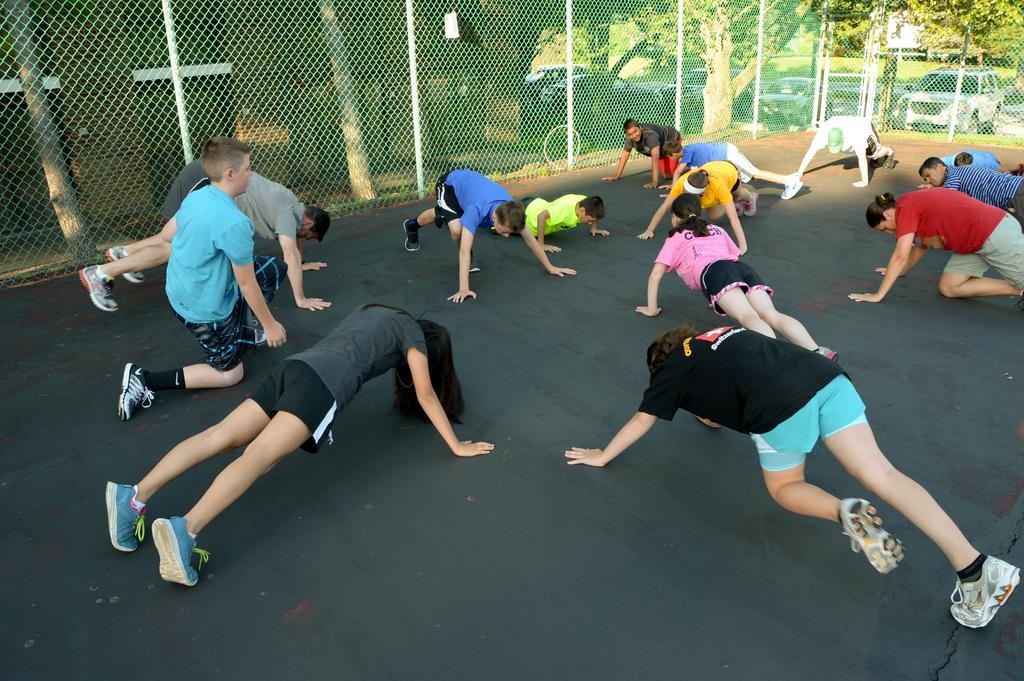Can you describe this image briefly? In this picture we can see a group of people on the floor, fencing net, building and in the background we can see the grass, vehicles, trees. 